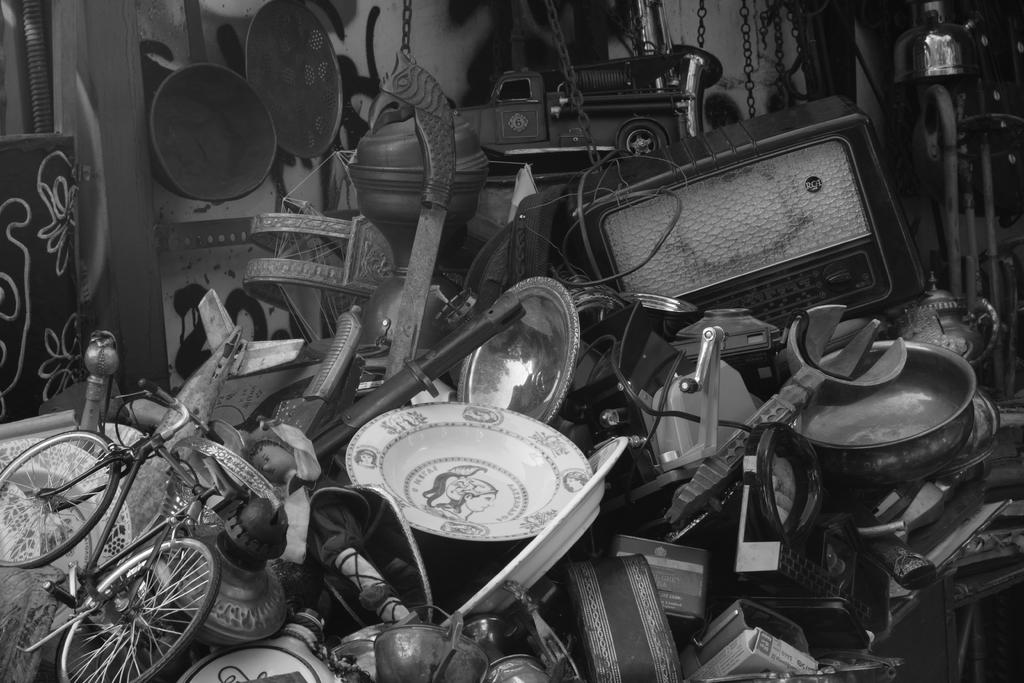What is the main object in the image? There is a bicycle in the image. What other items can be seen in the image besides the bicycle? There are plates, bowls, pans, chains, and a toy car visible in the image. What might be used for cooking or serving food in the image? Plates, bowls, and pans might be used for cooking or serving food in the image. What type of object is the toy car in the image? The toy car is a small-scale replica of a real car. Can you tell me how many visitors are present in the image? There is no reference to any visitors in the image. What type of shop is depicted in the image? There is no shop present in the image. 